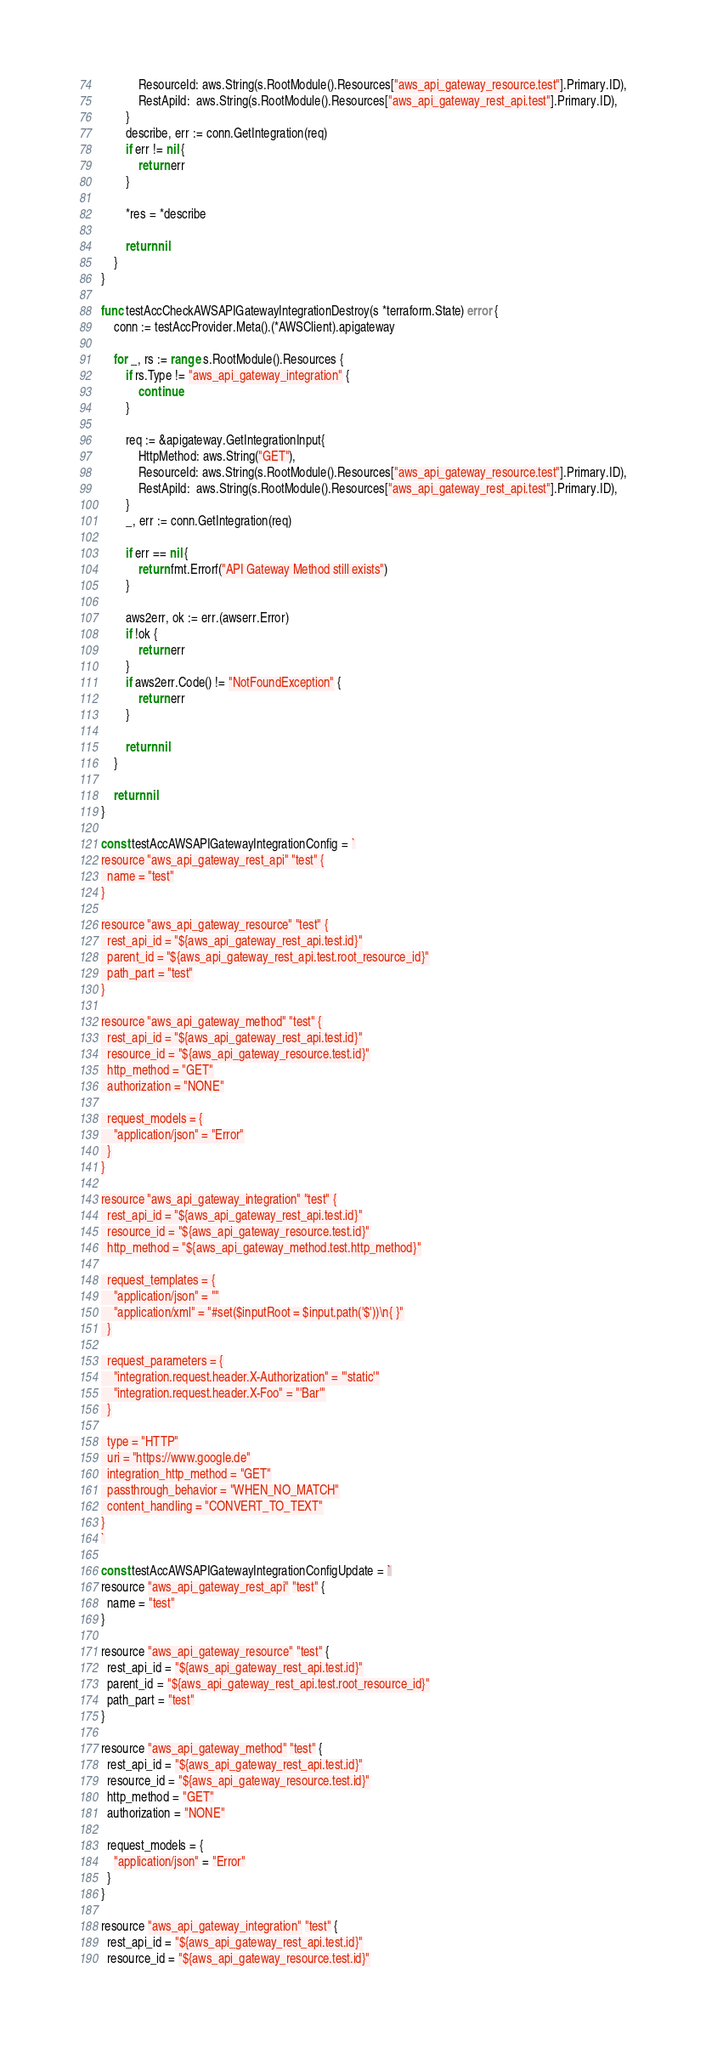<code> <loc_0><loc_0><loc_500><loc_500><_Go_>			ResourceId: aws.String(s.RootModule().Resources["aws_api_gateway_resource.test"].Primary.ID),
			RestApiId:  aws.String(s.RootModule().Resources["aws_api_gateway_rest_api.test"].Primary.ID),
		}
		describe, err := conn.GetIntegration(req)
		if err != nil {
			return err
		}

		*res = *describe

		return nil
	}
}

func testAccCheckAWSAPIGatewayIntegrationDestroy(s *terraform.State) error {
	conn := testAccProvider.Meta().(*AWSClient).apigateway

	for _, rs := range s.RootModule().Resources {
		if rs.Type != "aws_api_gateway_integration" {
			continue
		}

		req := &apigateway.GetIntegrationInput{
			HttpMethod: aws.String("GET"),
			ResourceId: aws.String(s.RootModule().Resources["aws_api_gateway_resource.test"].Primary.ID),
			RestApiId:  aws.String(s.RootModule().Resources["aws_api_gateway_rest_api.test"].Primary.ID),
		}
		_, err := conn.GetIntegration(req)

		if err == nil {
			return fmt.Errorf("API Gateway Method still exists")
		}

		aws2err, ok := err.(awserr.Error)
		if !ok {
			return err
		}
		if aws2err.Code() != "NotFoundException" {
			return err
		}

		return nil
	}

	return nil
}

const testAccAWSAPIGatewayIntegrationConfig = `
resource "aws_api_gateway_rest_api" "test" {
  name = "test"
}

resource "aws_api_gateway_resource" "test" {
  rest_api_id = "${aws_api_gateway_rest_api.test.id}"
  parent_id = "${aws_api_gateway_rest_api.test.root_resource_id}"
  path_part = "test"
}

resource "aws_api_gateway_method" "test" {
  rest_api_id = "${aws_api_gateway_rest_api.test.id}"
  resource_id = "${aws_api_gateway_resource.test.id}"
  http_method = "GET"
  authorization = "NONE"

  request_models = {
    "application/json" = "Error"
  }
}

resource "aws_api_gateway_integration" "test" {
  rest_api_id = "${aws_api_gateway_rest_api.test.id}"
  resource_id = "${aws_api_gateway_resource.test.id}"
  http_method = "${aws_api_gateway_method.test.http_method}"

  request_templates = {
    "application/json" = ""
    "application/xml" = "#set($inputRoot = $input.path('$'))\n{ }"
  }

  request_parameters = {
    "integration.request.header.X-Authorization" = "'static'"
    "integration.request.header.X-Foo" = "'Bar'"
  }

  type = "HTTP"
  uri = "https://www.google.de"
  integration_http_method = "GET"
  passthrough_behavior = "WHEN_NO_MATCH"
  content_handling = "CONVERT_TO_TEXT"
}
`

const testAccAWSAPIGatewayIntegrationConfigUpdate = `
resource "aws_api_gateway_rest_api" "test" {
  name = "test"
}

resource "aws_api_gateway_resource" "test" {
  rest_api_id = "${aws_api_gateway_rest_api.test.id}"
  parent_id = "${aws_api_gateway_rest_api.test.root_resource_id}"
  path_part = "test"
}

resource "aws_api_gateway_method" "test" {
  rest_api_id = "${aws_api_gateway_rest_api.test.id}"
  resource_id = "${aws_api_gateway_resource.test.id}"
  http_method = "GET"
  authorization = "NONE"

  request_models = {
    "application/json" = "Error"
  }
}

resource "aws_api_gateway_integration" "test" {
  rest_api_id = "${aws_api_gateway_rest_api.test.id}"
  resource_id = "${aws_api_gateway_resource.test.id}"</code> 